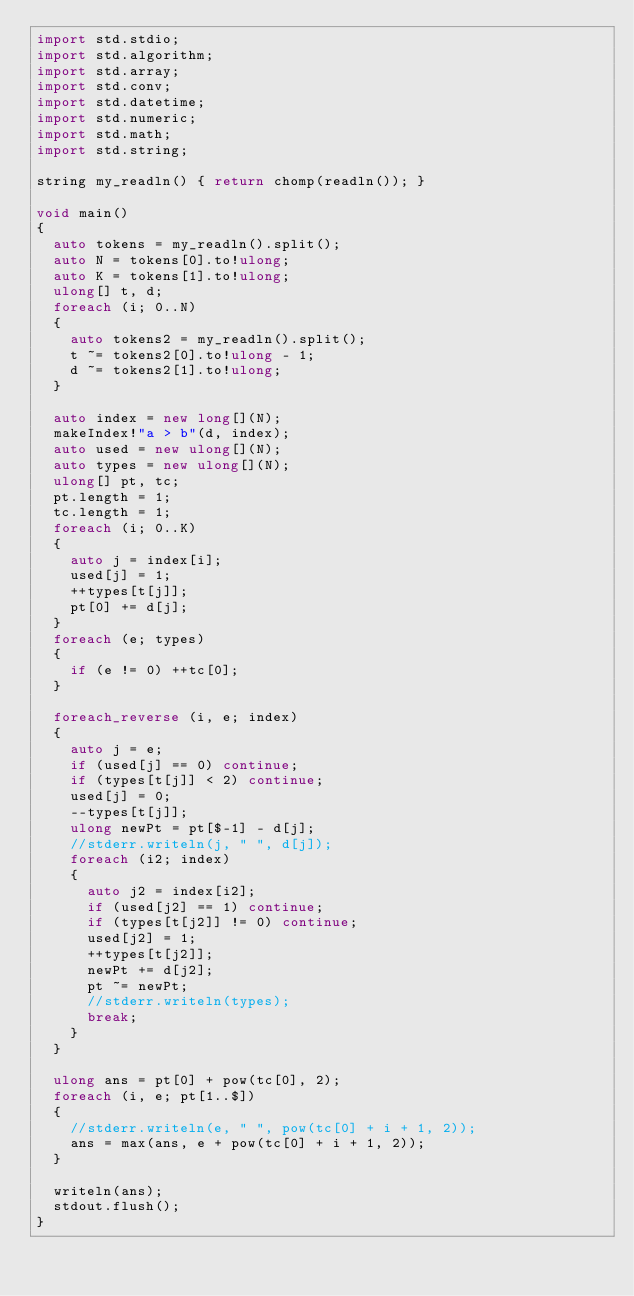<code> <loc_0><loc_0><loc_500><loc_500><_D_>import std.stdio;
import std.algorithm;
import std.array;
import std.conv;
import std.datetime;
import std.numeric;
import std.math;
import std.string;

string my_readln() { return chomp(readln()); }

void main()
{
	auto tokens = my_readln().split();
	auto N = tokens[0].to!ulong;
	auto K = tokens[1].to!ulong;
	ulong[] t, d;
	foreach (i; 0..N)
	{
		auto tokens2 = my_readln().split();
		t ~= tokens2[0].to!ulong - 1;
		d ~= tokens2[1].to!ulong;
	}
	
	auto index = new long[](N);
	makeIndex!"a > b"(d, index);
	auto used = new ulong[](N);
	auto types = new ulong[](N);
	ulong[] pt, tc;
	pt.length = 1;
	tc.length = 1;
	foreach (i; 0..K)
	{
		auto j = index[i];
		used[j] = 1;
		++types[t[j]];
		pt[0] += d[j];
	}
	foreach (e; types)
	{
		if (e != 0) ++tc[0];
	}

	foreach_reverse (i, e; index)
	{
		auto j = e;
		if (used[j] == 0) continue;
		if (types[t[j]] < 2) continue;
		used[j] = 0;
		--types[t[j]];
		ulong newPt = pt[$-1] - d[j];
		//stderr.writeln(j, " ", d[j]);
		foreach (i2; index)
		{
			auto j2 = index[i2];
			if (used[j2] == 1) continue;
			if (types[t[j2]] != 0) continue;
			used[j2] = 1;
			++types[t[j2]];
			newPt += d[j2];
			pt ~= newPt;
			//stderr.writeln(types);
			break;
		}
	}

	ulong ans = pt[0] + pow(tc[0], 2);
	foreach (i, e; pt[1..$])
	{
		//stderr.writeln(e, " ", pow(tc[0] + i + 1, 2));
		ans = max(ans, e + pow(tc[0] + i + 1, 2));
	}

	writeln(ans);
	stdout.flush();
}</code> 